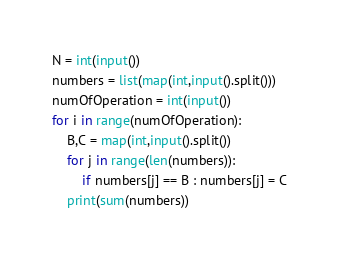Convert code to text. <code><loc_0><loc_0><loc_500><loc_500><_Python_>N = int(input())
numbers = list(map(int,input().split()))
numOfOperation = int(input())
for i in range(numOfOperation):
    B,C = map(int,input().split())
    for j in range(len(numbers)):
        if numbers[j] == B : numbers[j] = C
    print(sum(numbers))
</code> 